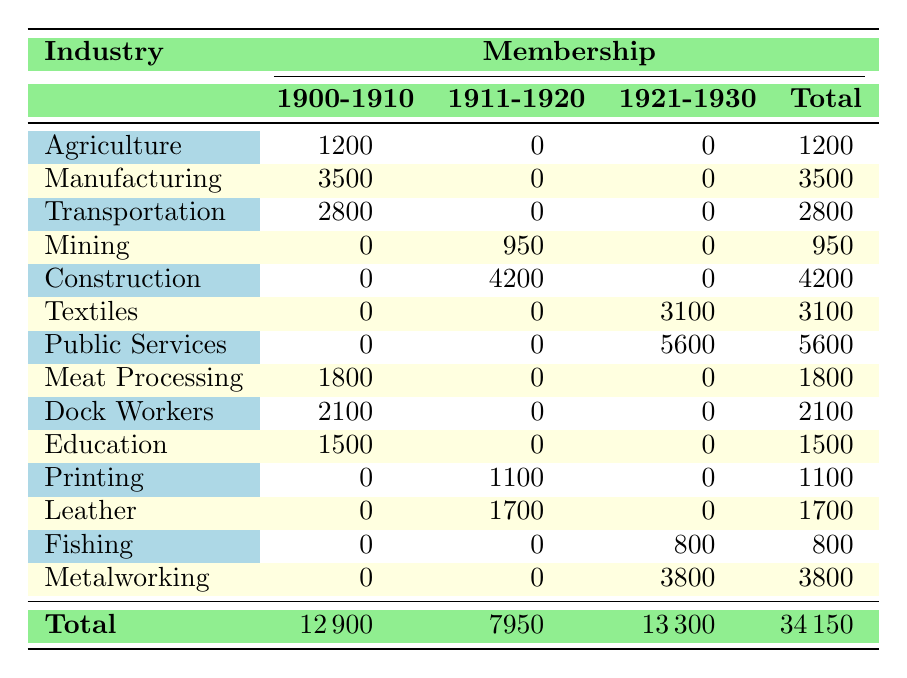What was the membership for Public Services in 1930? The table shows that the membership for the Public Services union in 1930 is 5600.
Answer: 5600 Which industry had the highest total membership across all years? By adding up the total membership for each industry, we find that Public Services has 5600, Construction 4200, Metalworking 3800, and others are lower. Thus, Public Services has the highest membership across all years.
Answer: Public Services Is there any industry that had membership only during the 1920-1930 period? Looking at the table, Fishing and Metalworking only have membership counts listed under the 1921-1930 category, which means they were exclusively active in that period.
Answer: Yes What is the average membership in the Mining industry over its recorded years? Mining has a total membership of 950 for the year 1915 and no memberships in the other years. Thus, the average is 950/1 = 950.
Answer: 950 What was the total membership in the Manufacturing industry over all years included? Manufacturing has a membership of 3500 in 1905 and none in the other years, leading to a total of 3500 for Manufacturing.
Answer: 3500 In which decade did the Construction industry see the most membership growth? Construction shows membership only in 1920 (4200), indicating it gained all of its membership during the 1921-1930 decade, as there are no memberships recorded before that.
Answer: 1921-1930 Did the Textile Workers Union experience a decrease in membership numbers from 1925 to 1930? The Textile Workers Union had no membership recorded in 1925, but it had 3100 in 1930. There was an increase rather than a decrease, indicating growth instead.
Answer: No Which industry had the lowest total membership over the years of observation? By calculating total memberships, Mining had the lowest total of 950, confirmed by its sole entry in 1915.
Answer: Mining How many different regions are represented in the table based on union membership? There are five regions represented in the table: Montevideo, Canelones, Salto, Rivera, Paysandú, Maldonado, Fray Bentos, Tacuarembó, Rocha. Counting unique entries, we find 8 different regions listed.
Answer: 8 